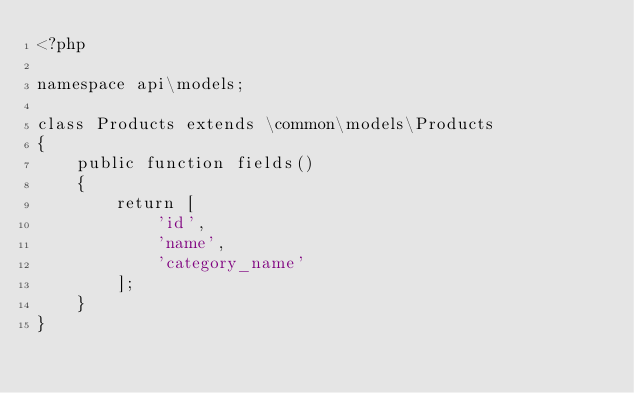<code> <loc_0><loc_0><loc_500><loc_500><_PHP_><?php

namespace api\models;

class Products extends \common\models\Products
{
    public function fields()
    {
        return [
            'id',
            'name',
            'category_name'
        ];
    }
}</code> 